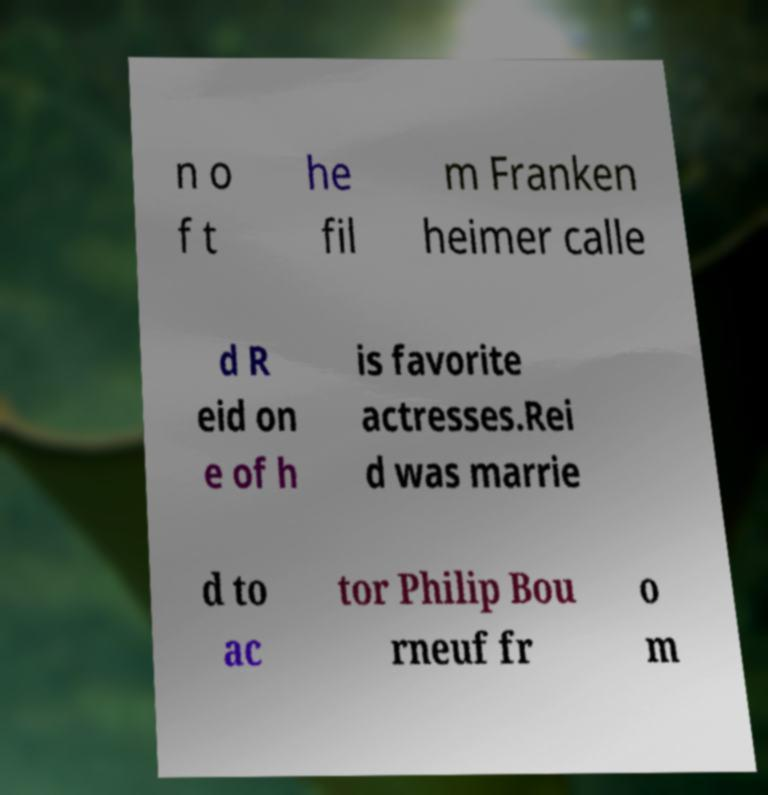Please read and relay the text visible in this image. What does it say? n o f t he fil m Franken heimer calle d R eid on e of h is favorite actresses.Rei d was marrie d to ac tor Philip Bou rneuf fr o m 